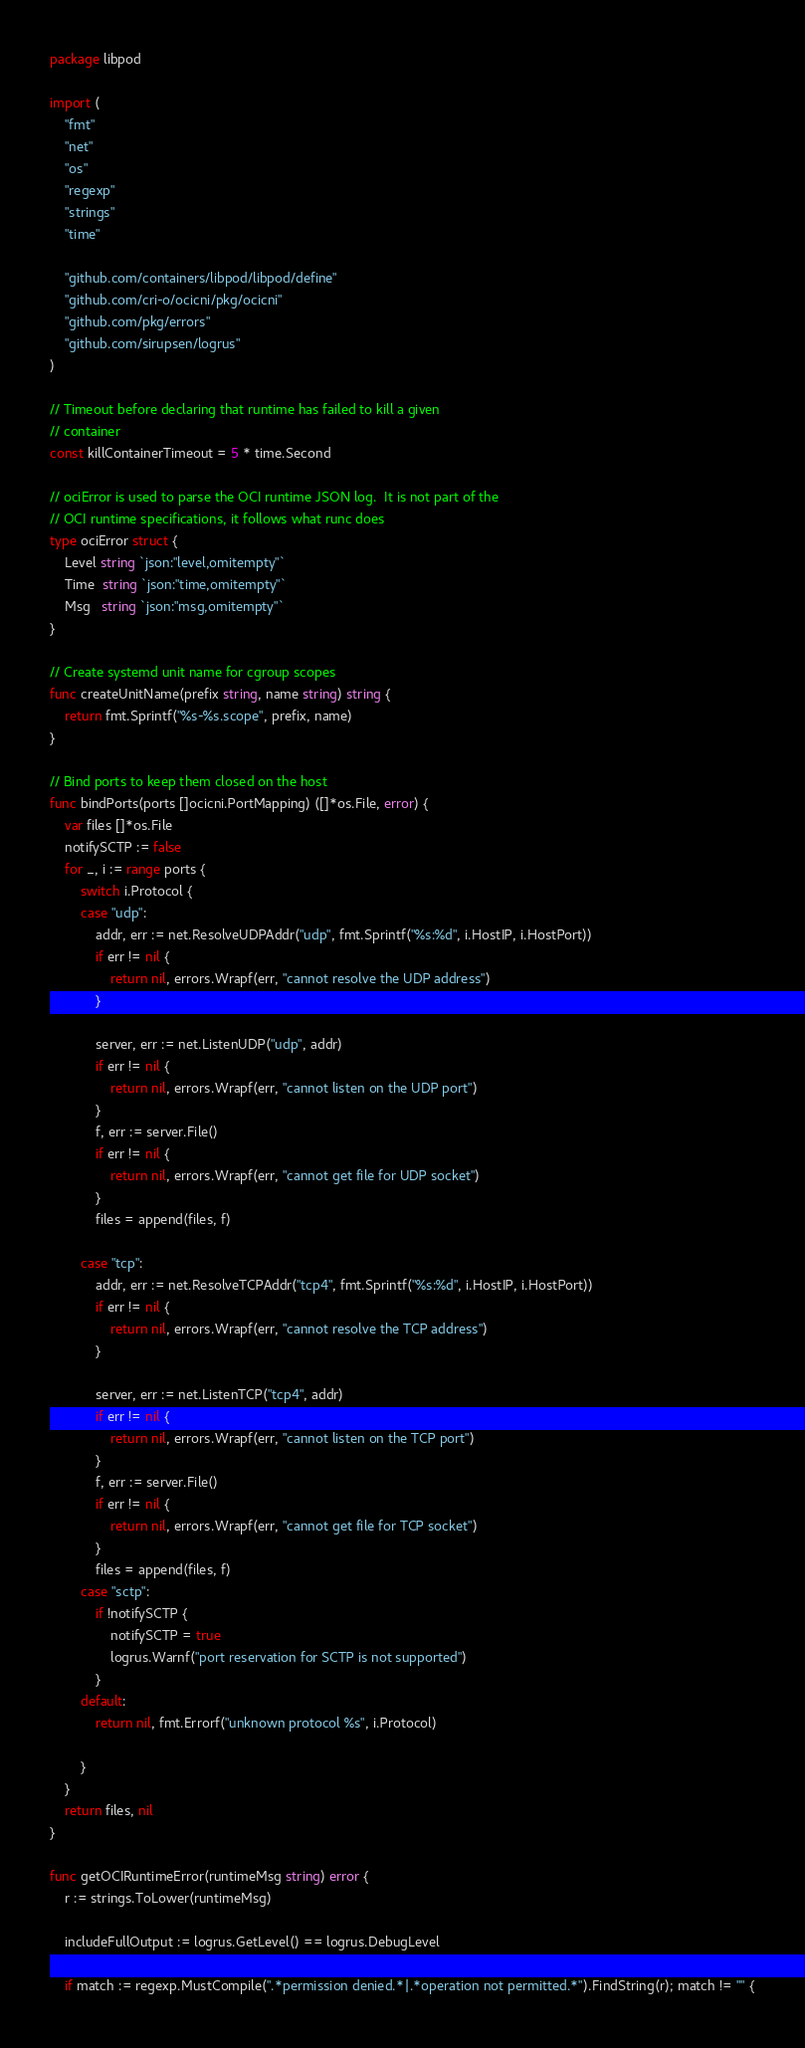<code> <loc_0><loc_0><loc_500><loc_500><_Go_>package libpod

import (
	"fmt"
	"net"
	"os"
	"regexp"
	"strings"
	"time"

	"github.com/containers/libpod/libpod/define"
	"github.com/cri-o/ocicni/pkg/ocicni"
	"github.com/pkg/errors"
	"github.com/sirupsen/logrus"
)

// Timeout before declaring that runtime has failed to kill a given
// container
const killContainerTimeout = 5 * time.Second

// ociError is used to parse the OCI runtime JSON log.  It is not part of the
// OCI runtime specifications, it follows what runc does
type ociError struct {
	Level string `json:"level,omitempty"`
	Time  string `json:"time,omitempty"`
	Msg   string `json:"msg,omitempty"`
}

// Create systemd unit name for cgroup scopes
func createUnitName(prefix string, name string) string {
	return fmt.Sprintf("%s-%s.scope", prefix, name)
}

// Bind ports to keep them closed on the host
func bindPorts(ports []ocicni.PortMapping) ([]*os.File, error) {
	var files []*os.File
	notifySCTP := false
	for _, i := range ports {
		switch i.Protocol {
		case "udp":
			addr, err := net.ResolveUDPAddr("udp", fmt.Sprintf("%s:%d", i.HostIP, i.HostPort))
			if err != nil {
				return nil, errors.Wrapf(err, "cannot resolve the UDP address")
			}

			server, err := net.ListenUDP("udp", addr)
			if err != nil {
				return nil, errors.Wrapf(err, "cannot listen on the UDP port")
			}
			f, err := server.File()
			if err != nil {
				return nil, errors.Wrapf(err, "cannot get file for UDP socket")
			}
			files = append(files, f)

		case "tcp":
			addr, err := net.ResolveTCPAddr("tcp4", fmt.Sprintf("%s:%d", i.HostIP, i.HostPort))
			if err != nil {
				return nil, errors.Wrapf(err, "cannot resolve the TCP address")
			}

			server, err := net.ListenTCP("tcp4", addr)
			if err != nil {
				return nil, errors.Wrapf(err, "cannot listen on the TCP port")
			}
			f, err := server.File()
			if err != nil {
				return nil, errors.Wrapf(err, "cannot get file for TCP socket")
			}
			files = append(files, f)
		case "sctp":
			if !notifySCTP {
				notifySCTP = true
				logrus.Warnf("port reservation for SCTP is not supported")
			}
		default:
			return nil, fmt.Errorf("unknown protocol %s", i.Protocol)

		}
	}
	return files, nil
}

func getOCIRuntimeError(runtimeMsg string) error {
	r := strings.ToLower(runtimeMsg)

	includeFullOutput := logrus.GetLevel() == logrus.DebugLevel

	if match := regexp.MustCompile(".*permission denied.*|.*operation not permitted.*").FindString(r); match != "" {</code> 